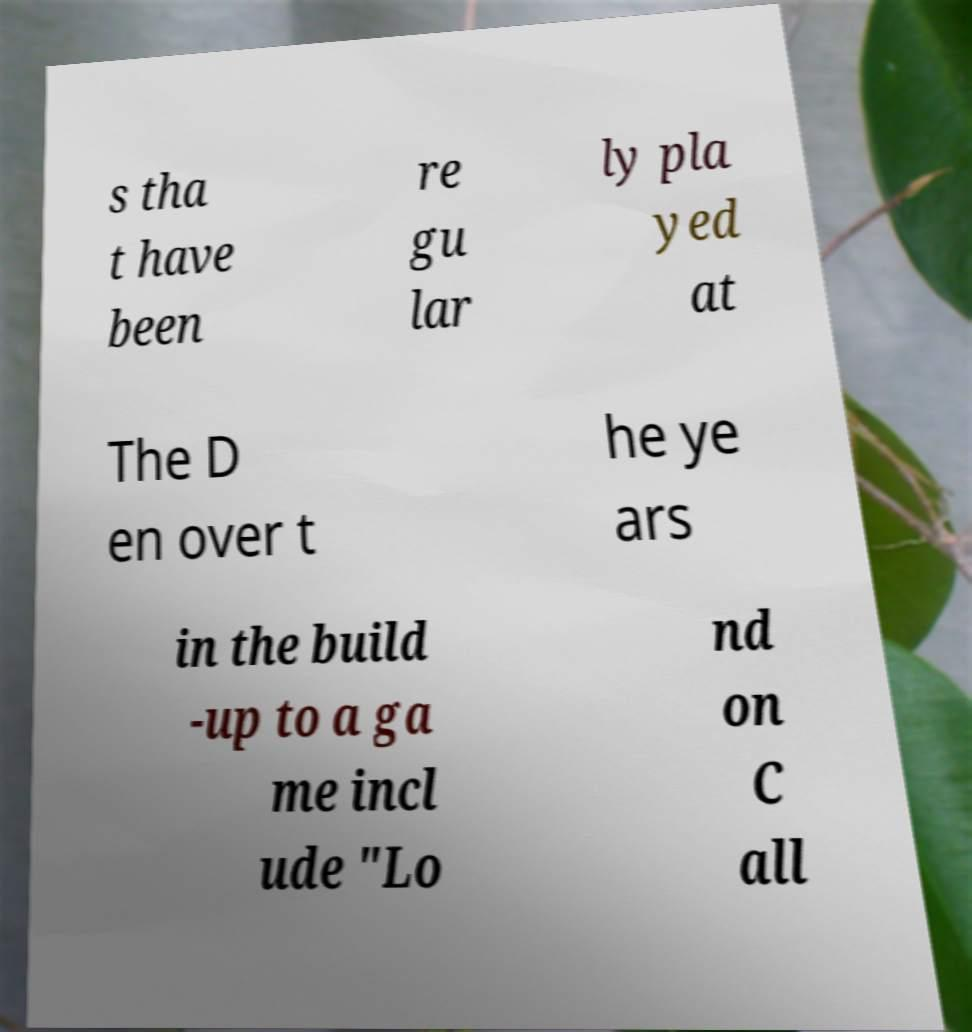Could you assist in decoding the text presented in this image and type it out clearly? s tha t have been re gu lar ly pla yed at The D en over t he ye ars in the build -up to a ga me incl ude "Lo nd on C all 